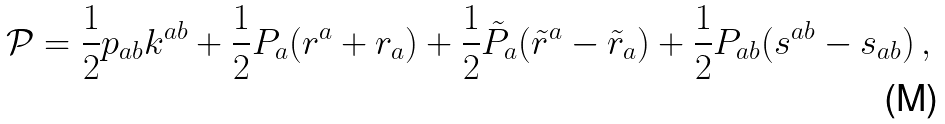<formula> <loc_0><loc_0><loc_500><loc_500>\mathcal { P } = \frac { 1 } { 2 } p _ { a b } k ^ { a b } + \frac { 1 } { 2 } P _ { a } ( r ^ { a } + r _ { a } ) + \frac { 1 } { 2 } \tilde { P } _ { a } ( \tilde { r } ^ { a } - \tilde { r } _ { a } ) + \frac { 1 } { 2 } P _ { a b } ( s ^ { a b } - s _ { a b } ) \, ,</formula> 